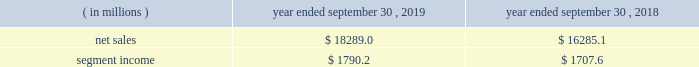Containerboard , kraft papers and saturating kraft .
Kapstone also owns victory packaging , a packaging solutions distribution company with facilities in the u.s. , canada and mexico .
We have included the financial results of kapstone in our corrugated packaging segment since the date of the acquisition .
On september 4 , 2018 , we completed the acquisition ( the 201cschl fcter acquisition 201d ) of schl fcter print pharma packaging ( 201cschl fcter 201d ) .
Schl fcter is a leading provider of differentiated paper and packaging solutions and a german-based supplier of a full range of leaflets and booklets .
The schl fcter acquisition allowed us to further enhance our pharmaceutical and automotive platform and expand our geographical footprint in europe to better serve our customers .
We have included the financial results of the acquired operations in our consumer packaging segment since the date of the acquisition .
On january 5 , 2018 , we completed the acquisition ( the 201cplymouth packaging acquisition 201d ) of substantially all of the assets of plymouth packaging , inc .
( 201cplymouth 201d ) .
The assets we acquired included plymouth 2019s 201cbox on demand 201d systems , which are manufactured by panotec , an italian manufacturer of packaging machines .
The addition of the box on demand systems enhanced our platform , differentiation and innovation .
These systems , which are located on customers 2019 sites under multi-year exclusive agreements , use fanfold corrugated to produce custom , on-demand corrugated packaging that is accurately sized for any product type according to the customer 2019s specifications .
Fanfold corrugated is continuous corrugated board , folded periodically to form an accordion-like stack of corrugated material .
As part of the transaction , westrock acquired plymouth 2019s equity interest in panotec and plymouth 2019s exclusive right from panotec to distribute panotec 2019s equipment in the u.s .
And canada .
We have fully integrated the approximately 60000 tons of containerboard used by plymouth annually .
We have included the financial results of plymouth in our corrugated packaging segment since the date of the acquisition .
See 201cnote 3 .
Acquisitions and investment 201d of the notes to consolidated financial statements for additional information .
See also item 1a .
201crisk factors 2014 we may be unsuccessful in making and integrating mergers , acquisitions and investments , and completing divestitures 201d .
Business .
In fiscal 2019 , we continued to pursue our strategy of offering differentiated paper and packaging solutions that help our customers win .
We successfully executed this strategy in fiscal 2019 in a rapidly changing cost and price environment .
Net sales of $ 18289.0 million for fiscal 2019 increased $ 2003.9 million , or 12.3% ( 12.3 % ) , compared to fiscal 2018 .
The increase was primarily due to the kapstone acquisition and higher selling price/mix in our corrugated packaging and consumer packaging segments .
These increases were partially offset by the absence of recycling net sales in fiscal 2019 as a result of conducting the operations primarily as a procurement function beginning in the first quarter of fiscal 2019 , lower volumes , unfavorable foreign currency impacts across our segments compared to the prior year and decreased land and development net sales .
Segment income increased $ 82.6 million in fiscal 2019 compared to fiscal 2018 , primarily due to increased corrugated packaging segment income that was partially offset by lower consumer packaging and land and development segment income .
The impact of the contribution from the acquired kapstone operations , higher selling price/mix across our segments and productivity improvements was largely offset by lower volumes across our segments , economic downtime , cost inflation , increased maintenance and scheduled strategic outage expense ( including projects at our mahrt , al and covington , va mills ) and lower land and development segment income due to the wind-down of sales .
With respect to segment income , we experienced higher levels of cost inflation in both our corrugated packaging and consumer packaging segments during fiscal 2019 as compared to fiscal 2018 that were partially offset by recovered fiber deflation .
The primary inflationary items were virgin fiber , freight , energy and wage and other costs .
We generated $ 2310.2 million of net cash provided by operating activities in fiscal 2019 , compared to $ 1931.2 million in fiscal 2018 .
We remained committed to our disciplined capital allocation strategy during fiscal .
In 2019 , what percent of sales does segment income amount to? 
Computations: (1790.2 / 18289.0)
Answer: 0.09788. 